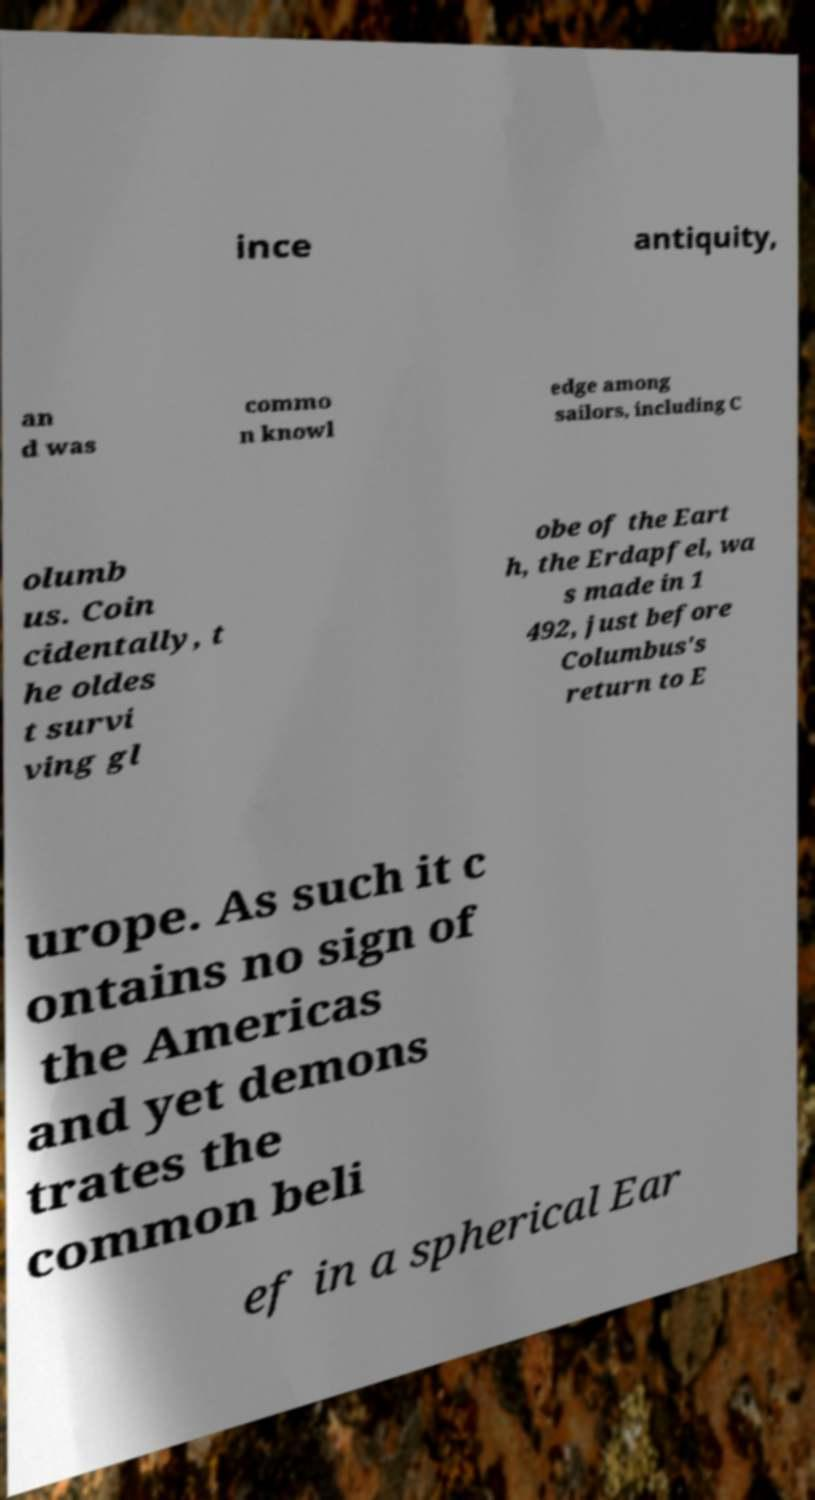I need the written content from this picture converted into text. Can you do that? ince antiquity, an d was commo n knowl edge among sailors, including C olumb us. Coin cidentally, t he oldes t survi ving gl obe of the Eart h, the Erdapfel, wa s made in 1 492, just before Columbus's return to E urope. As such it c ontains no sign of the Americas and yet demons trates the common beli ef in a spherical Ear 